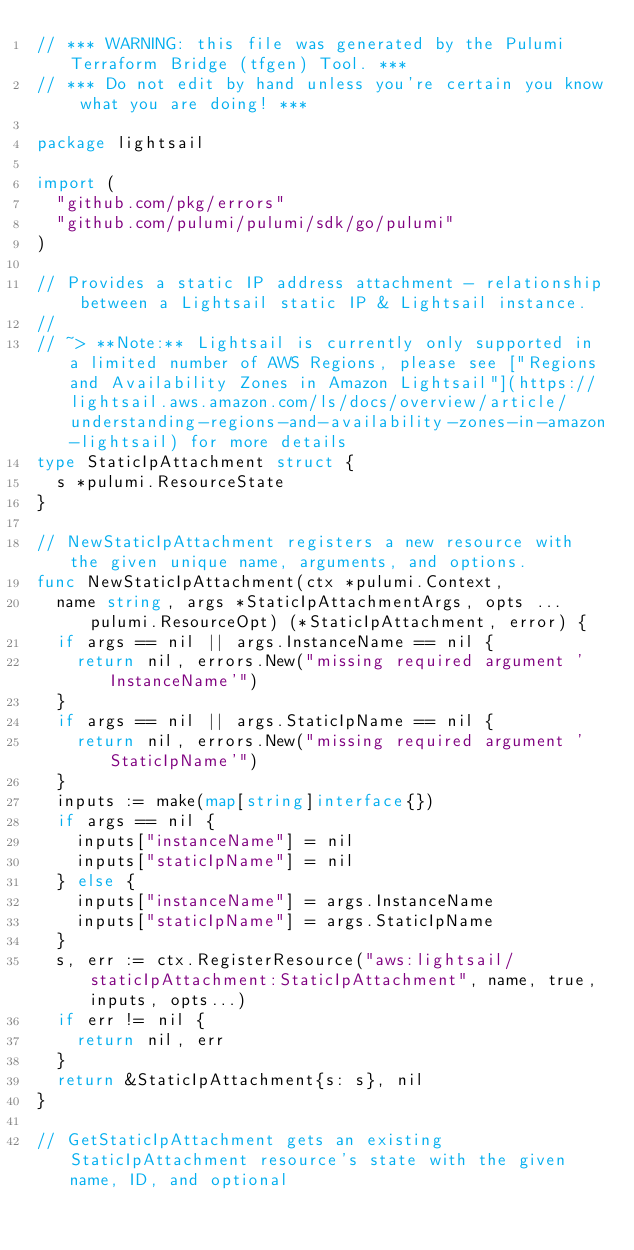<code> <loc_0><loc_0><loc_500><loc_500><_Go_>// *** WARNING: this file was generated by the Pulumi Terraform Bridge (tfgen) Tool. ***
// *** Do not edit by hand unless you're certain you know what you are doing! ***

package lightsail

import (
	"github.com/pkg/errors"
	"github.com/pulumi/pulumi/sdk/go/pulumi"
)

// Provides a static IP address attachment - relationship between a Lightsail static IP & Lightsail instance.
// 
// ~> **Note:** Lightsail is currently only supported in a limited number of AWS Regions, please see ["Regions and Availability Zones in Amazon Lightsail"](https://lightsail.aws.amazon.com/ls/docs/overview/article/understanding-regions-and-availability-zones-in-amazon-lightsail) for more details
type StaticIpAttachment struct {
	s *pulumi.ResourceState
}

// NewStaticIpAttachment registers a new resource with the given unique name, arguments, and options.
func NewStaticIpAttachment(ctx *pulumi.Context,
	name string, args *StaticIpAttachmentArgs, opts ...pulumi.ResourceOpt) (*StaticIpAttachment, error) {
	if args == nil || args.InstanceName == nil {
		return nil, errors.New("missing required argument 'InstanceName'")
	}
	if args == nil || args.StaticIpName == nil {
		return nil, errors.New("missing required argument 'StaticIpName'")
	}
	inputs := make(map[string]interface{})
	if args == nil {
		inputs["instanceName"] = nil
		inputs["staticIpName"] = nil
	} else {
		inputs["instanceName"] = args.InstanceName
		inputs["staticIpName"] = args.StaticIpName
	}
	s, err := ctx.RegisterResource("aws:lightsail/staticIpAttachment:StaticIpAttachment", name, true, inputs, opts...)
	if err != nil {
		return nil, err
	}
	return &StaticIpAttachment{s: s}, nil
}

// GetStaticIpAttachment gets an existing StaticIpAttachment resource's state with the given name, ID, and optional</code> 